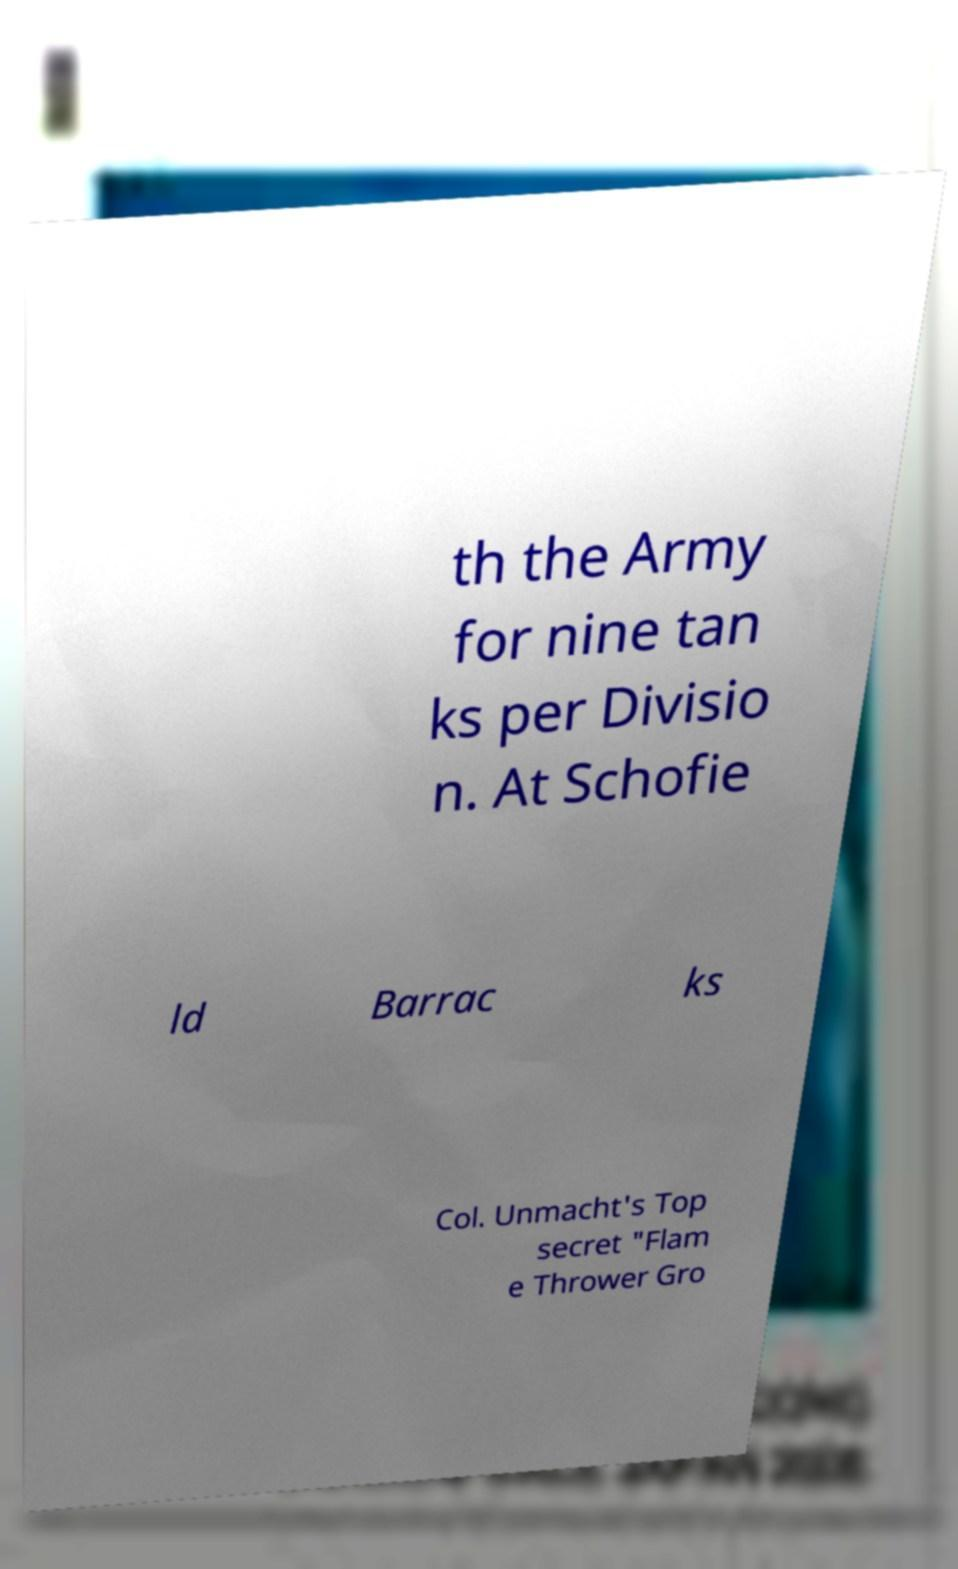Can you accurately transcribe the text from the provided image for me? th the Army for nine tan ks per Divisio n. At Schofie ld Barrac ks Col. Unmacht's Top secret "Flam e Thrower Gro 